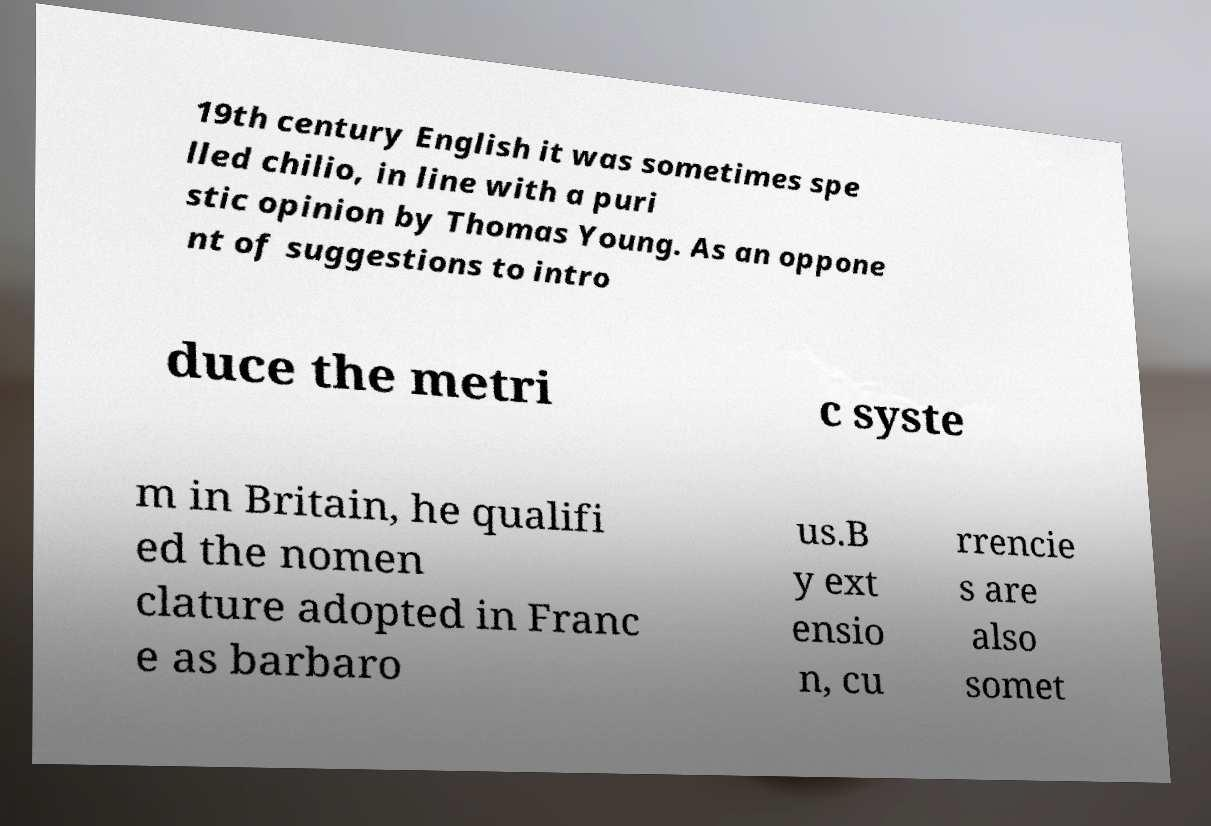There's text embedded in this image that I need extracted. Can you transcribe it verbatim? 19th century English it was sometimes spe lled chilio, in line with a puri stic opinion by Thomas Young. As an oppone nt of suggestions to intro duce the metri c syste m in Britain, he qualifi ed the nomen clature adopted in Franc e as barbaro us.B y ext ensio n, cu rrencie s are also somet 